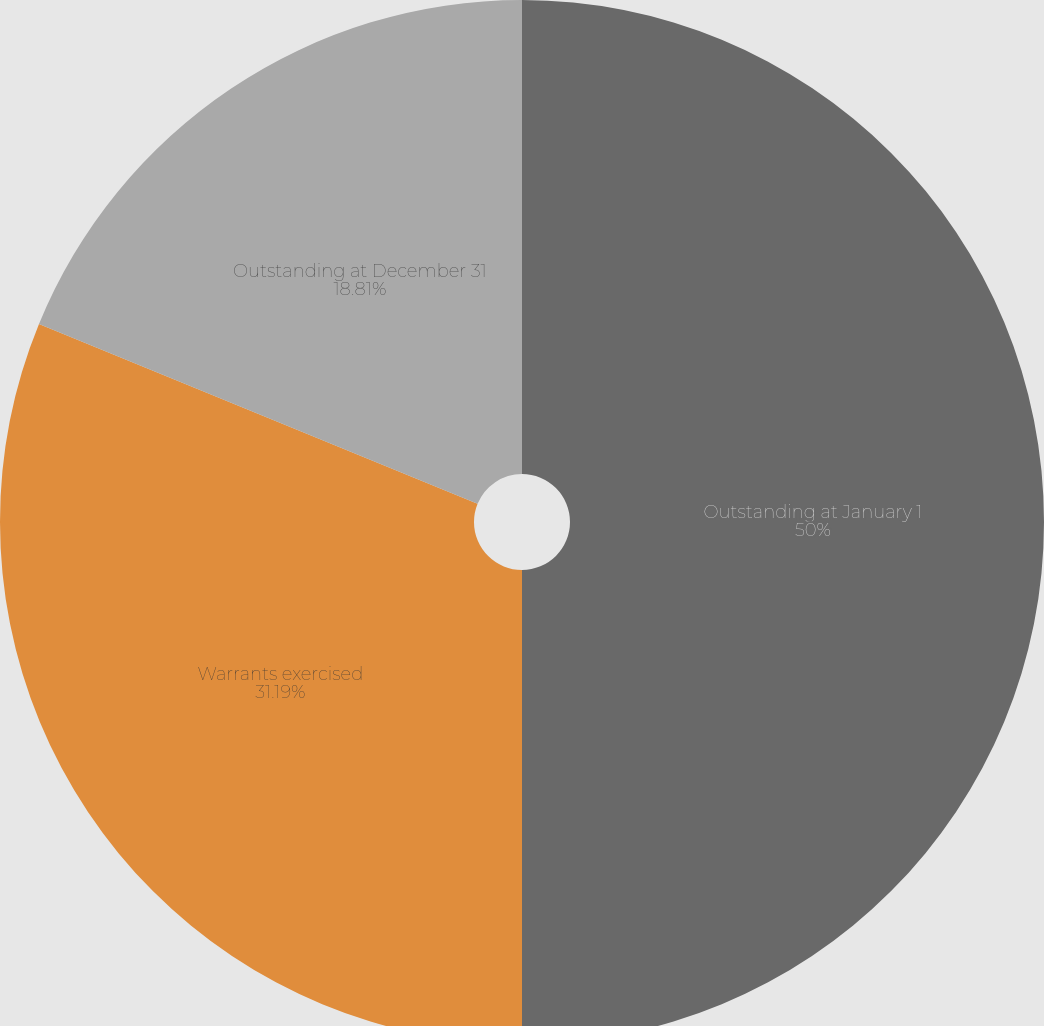Convert chart. <chart><loc_0><loc_0><loc_500><loc_500><pie_chart><fcel>Outstanding at January 1<fcel>Warrants exercised<fcel>Outstanding at December 31<nl><fcel>50.0%<fcel>31.19%<fcel>18.81%<nl></chart> 